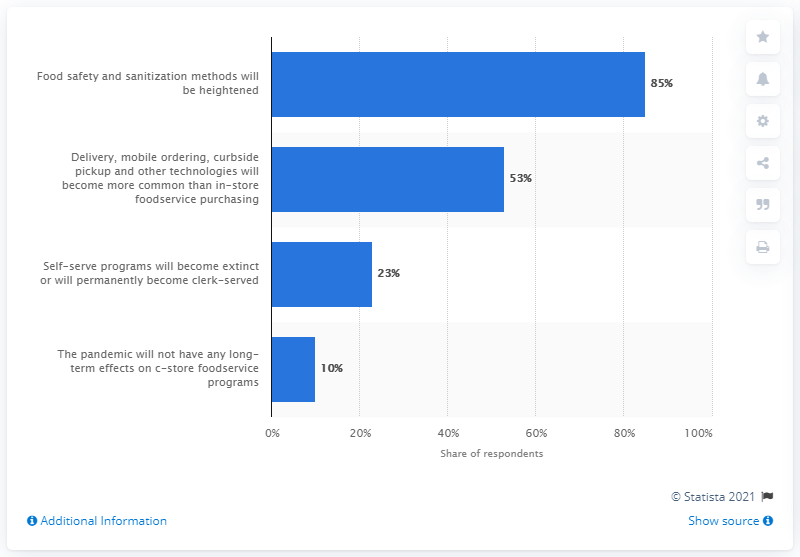Draw attention to some important aspects in this diagram. According to a recent survey, 85% of retailers predict that food safety and sanitization methods will be enhanced in foodservice operations over the long-term. 